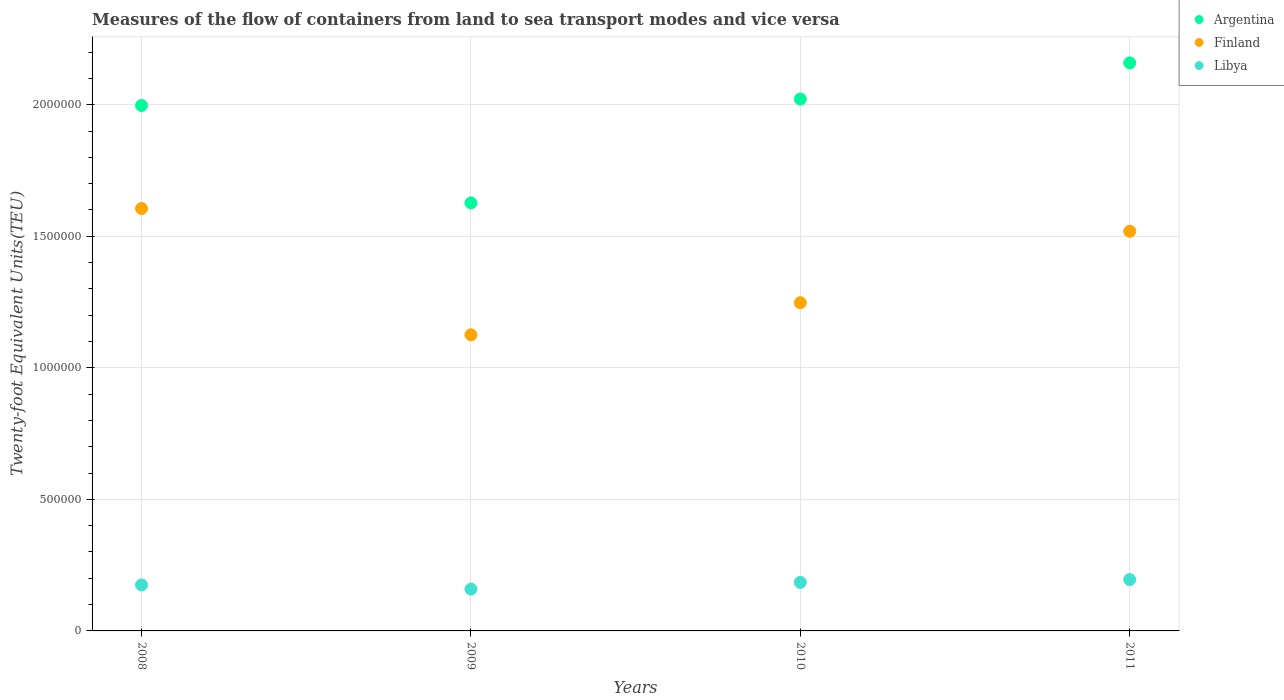Is the number of dotlines equal to the number of legend labels?
Provide a succinct answer. Yes. What is the container port traffic in Argentina in 2011?
Give a very brief answer. 2.16e+06. Across all years, what is the maximum container port traffic in Libya?
Your answer should be very brief. 1.95e+05. Across all years, what is the minimum container port traffic in Finland?
Ensure brevity in your answer.  1.13e+06. In which year was the container port traffic in Libya maximum?
Give a very brief answer. 2011. What is the total container port traffic in Argentina in the graph?
Provide a short and direct response. 7.80e+06. What is the difference between the container port traffic in Finland in 2008 and that in 2009?
Provide a short and direct response. 4.80e+05. What is the difference between the container port traffic in Finland in 2008 and the container port traffic in Argentina in 2009?
Your answer should be compact. -2.13e+04. What is the average container port traffic in Finland per year?
Offer a terse response. 1.37e+06. In the year 2010, what is the difference between the container port traffic in Argentina and container port traffic in Finland?
Keep it short and to the point. 7.74e+05. What is the ratio of the container port traffic in Argentina in 2010 to that in 2011?
Provide a succinct answer. 0.94. Is the container port traffic in Finland in 2010 less than that in 2011?
Make the answer very short. Yes. What is the difference between the highest and the second highest container port traffic in Finland?
Your answer should be very brief. 8.64e+04. What is the difference between the highest and the lowest container port traffic in Libya?
Provide a short and direct response. 3.61e+04. Is the sum of the container port traffic in Finland in 2009 and 2010 greater than the maximum container port traffic in Libya across all years?
Ensure brevity in your answer.  Yes. Does the container port traffic in Argentina monotonically increase over the years?
Keep it short and to the point. No. How many dotlines are there?
Keep it short and to the point. 3. What is the difference between two consecutive major ticks on the Y-axis?
Keep it short and to the point. 5.00e+05. Does the graph contain grids?
Offer a terse response. Yes. What is the title of the graph?
Make the answer very short. Measures of the flow of containers from land to sea transport modes and vice versa. Does "Macao" appear as one of the legend labels in the graph?
Your answer should be very brief. No. What is the label or title of the Y-axis?
Ensure brevity in your answer.  Twenty-foot Equivalent Units(TEU). What is the Twenty-foot Equivalent Units(TEU) of Argentina in 2008?
Provide a succinct answer. 2.00e+06. What is the Twenty-foot Equivalent Units(TEU) of Finland in 2008?
Your answer should be very brief. 1.61e+06. What is the Twenty-foot Equivalent Units(TEU) in Libya in 2008?
Your answer should be compact. 1.75e+05. What is the Twenty-foot Equivalent Units(TEU) in Argentina in 2009?
Keep it short and to the point. 1.63e+06. What is the Twenty-foot Equivalent Units(TEU) in Finland in 2009?
Offer a terse response. 1.13e+06. What is the Twenty-foot Equivalent Units(TEU) of Libya in 2009?
Offer a terse response. 1.59e+05. What is the Twenty-foot Equivalent Units(TEU) in Argentina in 2010?
Give a very brief answer. 2.02e+06. What is the Twenty-foot Equivalent Units(TEU) in Finland in 2010?
Your answer should be very brief. 1.25e+06. What is the Twenty-foot Equivalent Units(TEU) of Libya in 2010?
Your answer should be very brief. 1.85e+05. What is the Twenty-foot Equivalent Units(TEU) in Argentina in 2011?
Make the answer very short. 2.16e+06. What is the Twenty-foot Equivalent Units(TEU) in Finland in 2011?
Keep it short and to the point. 1.52e+06. What is the Twenty-foot Equivalent Units(TEU) in Libya in 2011?
Offer a terse response. 1.95e+05. Across all years, what is the maximum Twenty-foot Equivalent Units(TEU) of Argentina?
Your answer should be very brief. 2.16e+06. Across all years, what is the maximum Twenty-foot Equivalent Units(TEU) of Finland?
Keep it short and to the point. 1.61e+06. Across all years, what is the maximum Twenty-foot Equivalent Units(TEU) in Libya?
Keep it short and to the point. 1.95e+05. Across all years, what is the minimum Twenty-foot Equivalent Units(TEU) of Argentina?
Your response must be concise. 1.63e+06. Across all years, what is the minimum Twenty-foot Equivalent Units(TEU) in Finland?
Keep it short and to the point. 1.13e+06. Across all years, what is the minimum Twenty-foot Equivalent Units(TEU) of Libya?
Your answer should be compact. 1.59e+05. What is the total Twenty-foot Equivalent Units(TEU) of Argentina in the graph?
Keep it short and to the point. 7.80e+06. What is the total Twenty-foot Equivalent Units(TEU) in Finland in the graph?
Your answer should be compact. 5.50e+06. What is the total Twenty-foot Equivalent Units(TEU) of Libya in the graph?
Provide a succinct answer. 7.14e+05. What is the difference between the Twenty-foot Equivalent Units(TEU) of Argentina in 2008 and that in 2009?
Your response must be concise. 3.70e+05. What is the difference between the Twenty-foot Equivalent Units(TEU) in Finland in 2008 and that in 2009?
Provide a succinct answer. 4.80e+05. What is the difference between the Twenty-foot Equivalent Units(TEU) in Libya in 2008 and that in 2009?
Your response must be concise. 1.58e+04. What is the difference between the Twenty-foot Equivalent Units(TEU) of Argentina in 2008 and that in 2010?
Ensure brevity in your answer.  -2.45e+04. What is the difference between the Twenty-foot Equivalent Units(TEU) in Finland in 2008 and that in 2010?
Provide a short and direct response. 3.58e+05. What is the difference between the Twenty-foot Equivalent Units(TEU) in Libya in 2008 and that in 2010?
Your answer should be compact. -9757.69. What is the difference between the Twenty-foot Equivalent Units(TEU) of Argentina in 2008 and that in 2011?
Provide a short and direct response. -1.62e+05. What is the difference between the Twenty-foot Equivalent Units(TEU) of Finland in 2008 and that in 2011?
Ensure brevity in your answer.  8.64e+04. What is the difference between the Twenty-foot Equivalent Units(TEU) of Libya in 2008 and that in 2011?
Keep it short and to the point. -2.03e+04. What is the difference between the Twenty-foot Equivalent Units(TEU) in Argentina in 2009 and that in 2010?
Make the answer very short. -3.95e+05. What is the difference between the Twenty-foot Equivalent Units(TEU) in Finland in 2009 and that in 2010?
Give a very brief answer. -1.22e+05. What is the difference between the Twenty-foot Equivalent Units(TEU) of Libya in 2009 and that in 2010?
Offer a terse response. -2.56e+04. What is the difference between the Twenty-foot Equivalent Units(TEU) in Argentina in 2009 and that in 2011?
Make the answer very short. -5.32e+05. What is the difference between the Twenty-foot Equivalent Units(TEU) in Finland in 2009 and that in 2011?
Give a very brief answer. -3.94e+05. What is the difference between the Twenty-foot Equivalent Units(TEU) of Libya in 2009 and that in 2011?
Your answer should be compact. -3.61e+04. What is the difference between the Twenty-foot Equivalent Units(TEU) of Argentina in 2010 and that in 2011?
Ensure brevity in your answer.  -1.37e+05. What is the difference between the Twenty-foot Equivalent Units(TEU) in Finland in 2010 and that in 2011?
Offer a terse response. -2.72e+05. What is the difference between the Twenty-foot Equivalent Units(TEU) of Libya in 2010 and that in 2011?
Offer a terse response. -1.05e+04. What is the difference between the Twenty-foot Equivalent Units(TEU) of Argentina in 2008 and the Twenty-foot Equivalent Units(TEU) of Finland in 2009?
Provide a short and direct response. 8.72e+05. What is the difference between the Twenty-foot Equivalent Units(TEU) of Argentina in 2008 and the Twenty-foot Equivalent Units(TEU) of Libya in 2009?
Give a very brief answer. 1.84e+06. What is the difference between the Twenty-foot Equivalent Units(TEU) in Finland in 2008 and the Twenty-foot Equivalent Units(TEU) in Libya in 2009?
Provide a succinct answer. 1.45e+06. What is the difference between the Twenty-foot Equivalent Units(TEU) in Argentina in 2008 and the Twenty-foot Equivalent Units(TEU) in Finland in 2010?
Ensure brevity in your answer.  7.50e+05. What is the difference between the Twenty-foot Equivalent Units(TEU) of Argentina in 2008 and the Twenty-foot Equivalent Units(TEU) of Libya in 2010?
Offer a very short reply. 1.81e+06. What is the difference between the Twenty-foot Equivalent Units(TEU) of Finland in 2008 and the Twenty-foot Equivalent Units(TEU) of Libya in 2010?
Keep it short and to the point. 1.42e+06. What is the difference between the Twenty-foot Equivalent Units(TEU) in Argentina in 2008 and the Twenty-foot Equivalent Units(TEU) in Finland in 2011?
Keep it short and to the point. 4.78e+05. What is the difference between the Twenty-foot Equivalent Units(TEU) of Argentina in 2008 and the Twenty-foot Equivalent Units(TEU) of Libya in 2011?
Ensure brevity in your answer.  1.80e+06. What is the difference between the Twenty-foot Equivalent Units(TEU) in Finland in 2008 and the Twenty-foot Equivalent Units(TEU) in Libya in 2011?
Your response must be concise. 1.41e+06. What is the difference between the Twenty-foot Equivalent Units(TEU) of Argentina in 2009 and the Twenty-foot Equivalent Units(TEU) of Finland in 2010?
Offer a terse response. 3.79e+05. What is the difference between the Twenty-foot Equivalent Units(TEU) in Argentina in 2009 and the Twenty-foot Equivalent Units(TEU) in Libya in 2010?
Your answer should be very brief. 1.44e+06. What is the difference between the Twenty-foot Equivalent Units(TEU) of Finland in 2009 and the Twenty-foot Equivalent Units(TEU) of Libya in 2010?
Make the answer very short. 9.41e+05. What is the difference between the Twenty-foot Equivalent Units(TEU) in Argentina in 2009 and the Twenty-foot Equivalent Units(TEU) in Finland in 2011?
Offer a terse response. 1.08e+05. What is the difference between the Twenty-foot Equivalent Units(TEU) in Argentina in 2009 and the Twenty-foot Equivalent Units(TEU) in Libya in 2011?
Offer a very short reply. 1.43e+06. What is the difference between the Twenty-foot Equivalent Units(TEU) in Finland in 2009 and the Twenty-foot Equivalent Units(TEU) in Libya in 2011?
Keep it short and to the point. 9.30e+05. What is the difference between the Twenty-foot Equivalent Units(TEU) of Argentina in 2010 and the Twenty-foot Equivalent Units(TEU) of Finland in 2011?
Offer a very short reply. 5.03e+05. What is the difference between the Twenty-foot Equivalent Units(TEU) of Argentina in 2010 and the Twenty-foot Equivalent Units(TEU) of Libya in 2011?
Provide a succinct answer. 1.83e+06. What is the difference between the Twenty-foot Equivalent Units(TEU) in Finland in 2010 and the Twenty-foot Equivalent Units(TEU) in Libya in 2011?
Ensure brevity in your answer.  1.05e+06. What is the average Twenty-foot Equivalent Units(TEU) in Argentina per year?
Offer a terse response. 1.95e+06. What is the average Twenty-foot Equivalent Units(TEU) in Finland per year?
Your answer should be compact. 1.37e+06. What is the average Twenty-foot Equivalent Units(TEU) in Libya per year?
Keep it short and to the point. 1.78e+05. In the year 2008, what is the difference between the Twenty-foot Equivalent Units(TEU) in Argentina and Twenty-foot Equivalent Units(TEU) in Finland?
Ensure brevity in your answer.  3.92e+05. In the year 2008, what is the difference between the Twenty-foot Equivalent Units(TEU) in Argentina and Twenty-foot Equivalent Units(TEU) in Libya?
Make the answer very short. 1.82e+06. In the year 2008, what is the difference between the Twenty-foot Equivalent Units(TEU) of Finland and Twenty-foot Equivalent Units(TEU) of Libya?
Keep it short and to the point. 1.43e+06. In the year 2009, what is the difference between the Twenty-foot Equivalent Units(TEU) of Argentina and Twenty-foot Equivalent Units(TEU) of Finland?
Make the answer very short. 5.01e+05. In the year 2009, what is the difference between the Twenty-foot Equivalent Units(TEU) in Argentina and Twenty-foot Equivalent Units(TEU) in Libya?
Your response must be concise. 1.47e+06. In the year 2009, what is the difference between the Twenty-foot Equivalent Units(TEU) in Finland and Twenty-foot Equivalent Units(TEU) in Libya?
Offer a terse response. 9.67e+05. In the year 2010, what is the difference between the Twenty-foot Equivalent Units(TEU) in Argentina and Twenty-foot Equivalent Units(TEU) in Finland?
Offer a very short reply. 7.74e+05. In the year 2010, what is the difference between the Twenty-foot Equivalent Units(TEU) of Argentina and Twenty-foot Equivalent Units(TEU) of Libya?
Your response must be concise. 1.84e+06. In the year 2010, what is the difference between the Twenty-foot Equivalent Units(TEU) in Finland and Twenty-foot Equivalent Units(TEU) in Libya?
Offer a terse response. 1.06e+06. In the year 2011, what is the difference between the Twenty-foot Equivalent Units(TEU) in Argentina and Twenty-foot Equivalent Units(TEU) in Finland?
Your answer should be compact. 6.40e+05. In the year 2011, what is the difference between the Twenty-foot Equivalent Units(TEU) in Argentina and Twenty-foot Equivalent Units(TEU) in Libya?
Provide a short and direct response. 1.96e+06. In the year 2011, what is the difference between the Twenty-foot Equivalent Units(TEU) in Finland and Twenty-foot Equivalent Units(TEU) in Libya?
Ensure brevity in your answer.  1.32e+06. What is the ratio of the Twenty-foot Equivalent Units(TEU) in Argentina in 2008 to that in 2009?
Offer a very short reply. 1.23. What is the ratio of the Twenty-foot Equivalent Units(TEU) in Finland in 2008 to that in 2009?
Offer a terse response. 1.43. What is the ratio of the Twenty-foot Equivalent Units(TEU) in Libya in 2008 to that in 2009?
Keep it short and to the point. 1.1. What is the ratio of the Twenty-foot Equivalent Units(TEU) in Argentina in 2008 to that in 2010?
Offer a very short reply. 0.99. What is the ratio of the Twenty-foot Equivalent Units(TEU) of Finland in 2008 to that in 2010?
Offer a terse response. 1.29. What is the ratio of the Twenty-foot Equivalent Units(TEU) of Libya in 2008 to that in 2010?
Provide a short and direct response. 0.95. What is the ratio of the Twenty-foot Equivalent Units(TEU) in Argentina in 2008 to that in 2011?
Offer a terse response. 0.93. What is the ratio of the Twenty-foot Equivalent Units(TEU) of Finland in 2008 to that in 2011?
Your response must be concise. 1.06. What is the ratio of the Twenty-foot Equivalent Units(TEU) of Libya in 2008 to that in 2011?
Your answer should be very brief. 0.9. What is the ratio of the Twenty-foot Equivalent Units(TEU) in Argentina in 2009 to that in 2010?
Provide a succinct answer. 0.8. What is the ratio of the Twenty-foot Equivalent Units(TEU) of Finland in 2009 to that in 2010?
Offer a very short reply. 0.9. What is the ratio of the Twenty-foot Equivalent Units(TEU) in Libya in 2009 to that in 2010?
Provide a succinct answer. 0.86. What is the ratio of the Twenty-foot Equivalent Units(TEU) in Argentina in 2009 to that in 2011?
Provide a succinct answer. 0.75. What is the ratio of the Twenty-foot Equivalent Units(TEU) of Finland in 2009 to that in 2011?
Offer a terse response. 0.74. What is the ratio of the Twenty-foot Equivalent Units(TEU) in Libya in 2009 to that in 2011?
Give a very brief answer. 0.81. What is the ratio of the Twenty-foot Equivalent Units(TEU) in Argentina in 2010 to that in 2011?
Ensure brevity in your answer.  0.94. What is the ratio of the Twenty-foot Equivalent Units(TEU) in Finland in 2010 to that in 2011?
Make the answer very short. 0.82. What is the ratio of the Twenty-foot Equivalent Units(TEU) in Libya in 2010 to that in 2011?
Your answer should be very brief. 0.95. What is the difference between the highest and the second highest Twenty-foot Equivalent Units(TEU) in Argentina?
Offer a terse response. 1.37e+05. What is the difference between the highest and the second highest Twenty-foot Equivalent Units(TEU) in Finland?
Make the answer very short. 8.64e+04. What is the difference between the highest and the second highest Twenty-foot Equivalent Units(TEU) of Libya?
Offer a very short reply. 1.05e+04. What is the difference between the highest and the lowest Twenty-foot Equivalent Units(TEU) of Argentina?
Ensure brevity in your answer.  5.32e+05. What is the difference between the highest and the lowest Twenty-foot Equivalent Units(TEU) in Finland?
Give a very brief answer. 4.80e+05. What is the difference between the highest and the lowest Twenty-foot Equivalent Units(TEU) in Libya?
Give a very brief answer. 3.61e+04. 